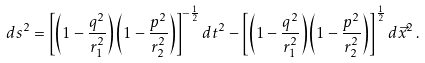<formula> <loc_0><loc_0><loc_500><loc_500>d s ^ { 2 } = \left [ \left ( 1 - \frac { q ^ { 2 } } { r _ { 1 } ^ { 2 } } \right ) \left ( 1 - \frac { p ^ { 2 } } { r _ { 2 } ^ { 2 } } \right ) \right ] ^ { - \frac { 1 } { 2 } } d t ^ { 2 } - \left [ \left ( 1 - \frac { q ^ { 2 } } { r _ { 1 } ^ { 2 } } \right ) \left ( 1 - \frac { p ^ { 2 } } { r _ { 2 } ^ { 2 } } \right ) \right ] ^ { \frac { 1 } { 2 } } d \vec { x } ^ { 2 } \, .</formula> 